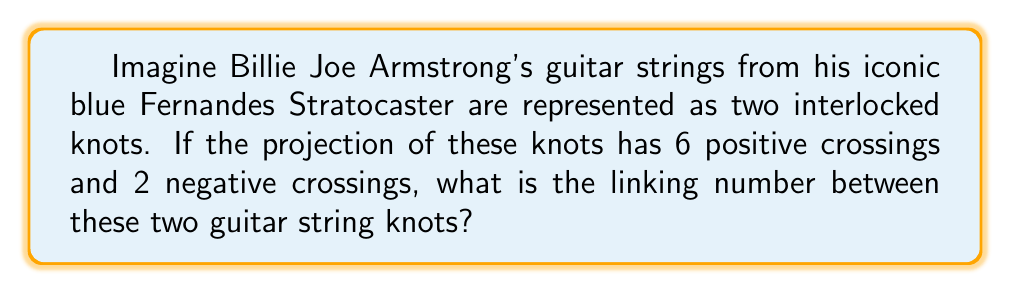Could you help me with this problem? To calculate the linking number between two interlocked knots, we follow these steps:

1. Identify the crossings in the projection of the knots.
2. Determine the sign of each crossing (positive or negative).
3. Count the number of positive and negative crossings.
4. Apply the formula for the linking number:

$$ Lk = \frac{1}{2}(n_+ - n_-) $$

Where:
$Lk$ is the linking number
$n_+$ is the number of positive crossings
$n_-$ is the number of negative crossings

In this case:
$n_+ = 6$ (given in the question)
$n_- = 2$ (given in the question)

Substituting these values into the formula:

$$ Lk = \frac{1}{2}(6 - 2) $$
$$ Lk = \frac{1}{2}(4) $$
$$ Lk = 2 $$

Therefore, the linking number between the two interlocked guitar string knots is 2.
Answer: 2 